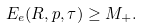Convert formula to latex. <formula><loc_0><loc_0><loc_500><loc_500>E _ { e } ( R , p , \tau ) \geq M _ { + } .</formula> 